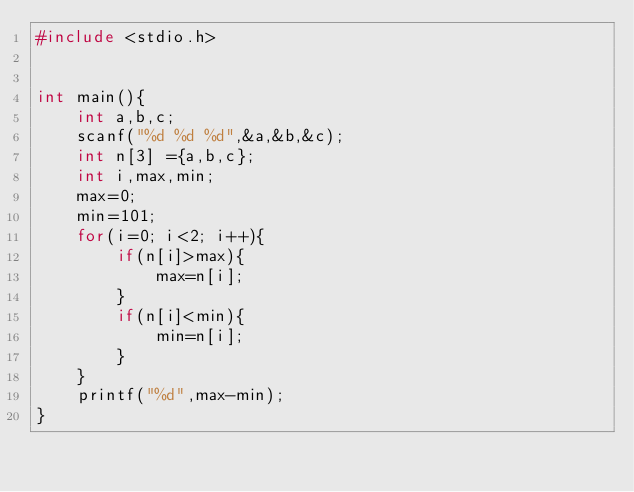<code> <loc_0><loc_0><loc_500><loc_500><_C_>#include <stdio.h>


int main(){
    int a,b,c;
    scanf("%d %d %d",&a,&b,&c);
    int n[3] ={a,b,c};
    int i,max,min;
    max=0;
    min=101;
    for(i=0; i<2; i++){
        if(n[i]>max){
            max=n[i];
        }
        if(n[i]<min){
            min=n[i];
        }
    }
    printf("%d",max-min);
}
</code> 